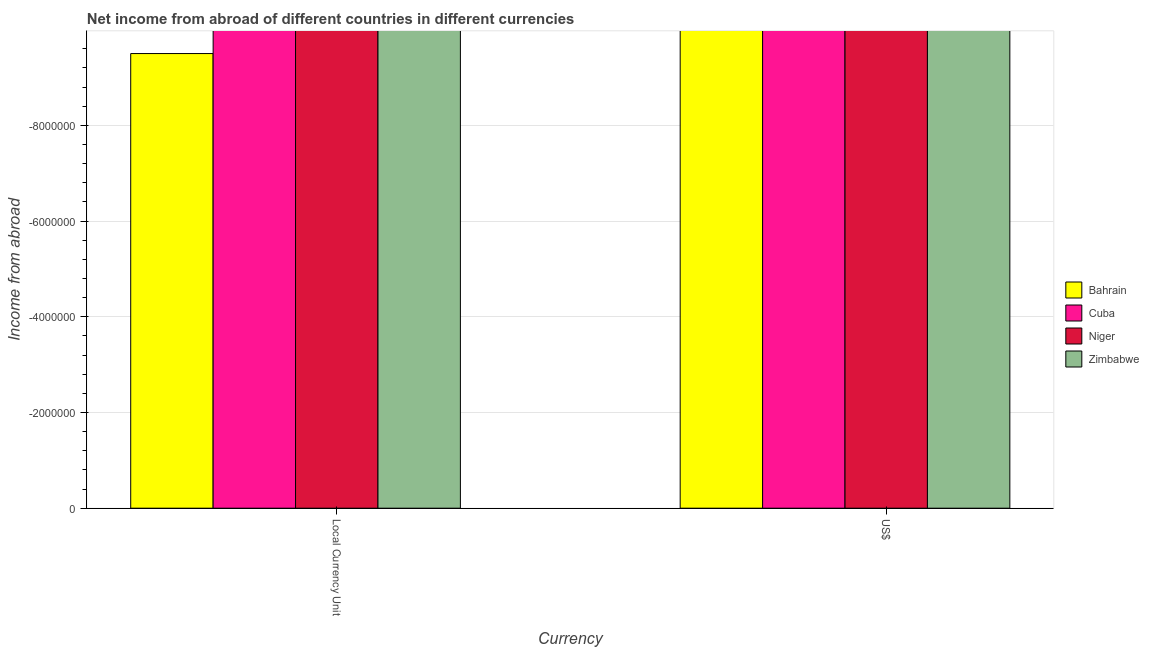How many bars are there on the 2nd tick from the right?
Your response must be concise. 0. What is the label of the 2nd group of bars from the left?
Your answer should be compact. US$. What is the income from abroad in constant 2005 us$ in Bahrain?
Ensure brevity in your answer.  0. What is the total income from abroad in constant 2005 us$ in the graph?
Offer a very short reply. 0. What is the average income from abroad in us$ per country?
Provide a succinct answer. 0. In how many countries, is the income from abroad in constant 2005 us$ greater than the average income from abroad in constant 2005 us$ taken over all countries?
Give a very brief answer. 0. Are all the bars in the graph horizontal?
Keep it short and to the point. No. How many countries are there in the graph?
Keep it short and to the point. 4. Does the graph contain any zero values?
Your answer should be very brief. Yes. Does the graph contain grids?
Provide a short and direct response. Yes. What is the title of the graph?
Your response must be concise. Net income from abroad of different countries in different currencies. What is the label or title of the X-axis?
Your answer should be very brief. Currency. What is the label or title of the Y-axis?
Your answer should be very brief. Income from abroad. What is the Income from abroad of Niger in Local Currency Unit?
Provide a succinct answer. 0. What is the Income from abroad of Bahrain in US$?
Your answer should be compact. 0. What is the Income from abroad of Cuba in US$?
Provide a succinct answer. 0. What is the Income from abroad in Zimbabwe in US$?
Your response must be concise. 0. What is the total Income from abroad of Bahrain in the graph?
Give a very brief answer. 0. What is the total Income from abroad in Niger in the graph?
Offer a very short reply. 0. What is the average Income from abroad of Bahrain per Currency?
Ensure brevity in your answer.  0. What is the average Income from abroad in Cuba per Currency?
Keep it short and to the point. 0. What is the average Income from abroad in Zimbabwe per Currency?
Your answer should be very brief. 0. 